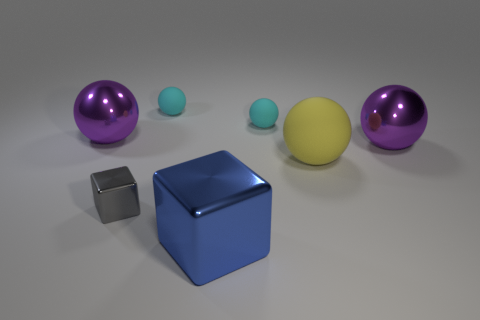Subtract all gray cubes. Subtract all gray balls. How many cubes are left? 1 Add 1 small cyan balls. How many objects exist? 8 Subtract all blocks. How many objects are left? 5 Subtract 0 cyan blocks. How many objects are left? 7 Subtract all big shiny objects. Subtract all big blue metallic objects. How many objects are left? 3 Add 3 small things. How many small things are left? 6 Add 7 large red metal cubes. How many large red metal cubes exist? 7 